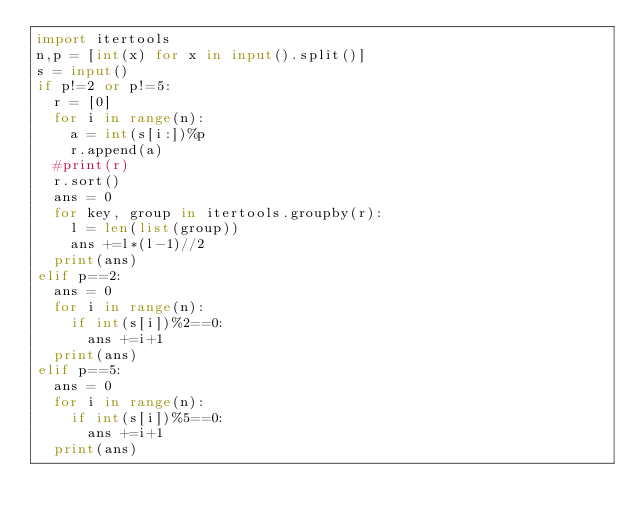<code> <loc_0><loc_0><loc_500><loc_500><_Python_>import itertools
n,p = [int(x) for x in input().split()]
s = input()
if p!=2 or p!=5:
  r = [0]
  for i in range(n):
    a = int(s[i:])%p
    r.append(a)
  #print(r)
  r.sort()
  ans = 0
  for key, group in itertools.groupby(r):
    l = len(list(group))
    ans +=l*(l-1)//2
  print(ans)
elif p==2:
  ans = 0
  for i in range(n):
    if int(s[i])%2==0:
      ans +=i+1
  print(ans)
elif p==5:
  ans = 0
  for i in range(n):
    if int(s[i])%5==0:
      ans +=i+1
  print(ans)</code> 